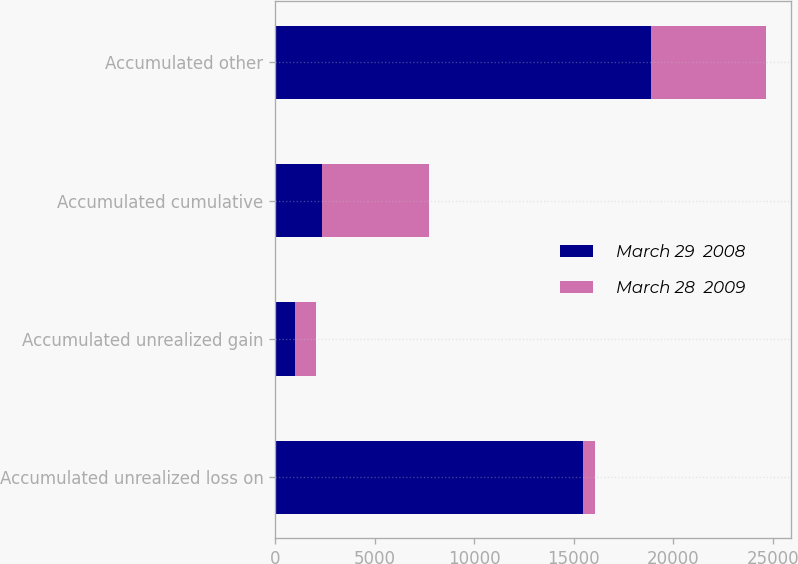Convert chart to OTSL. <chart><loc_0><loc_0><loc_500><loc_500><stacked_bar_chart><ecel><fcel>Accumulated unrealized loss on<fcel>Accumulated unrealized gain<fcel>Accumulated cumulative<fcel>Accumulated other<nl><fcel>March 29  2008<fcel>15474<fcel>1012<fcel>2372<fcel>18858<nl><fcel>March 28  2009<fcel>586<fcel>1027<fcel>5363<fcel>5804<nl></chart> 